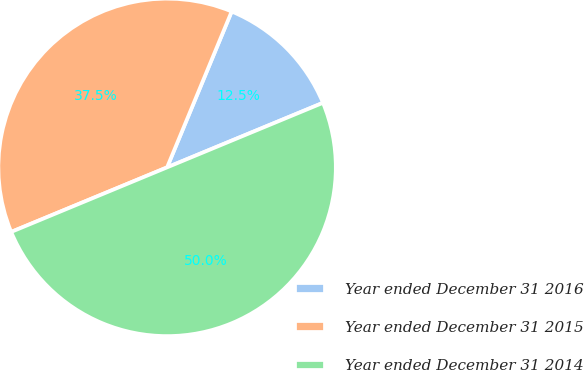<chart> <loc_0><loc_0><loc_500><loc_500><pie_chart><fcel>Year ended December 31 2016<fcel>Year ended December 31 2015<fcel>Year ended December 31 2014<nl><fcel>12.5%<fcel>37.5%<fcel>50.0%<nl></chart> 